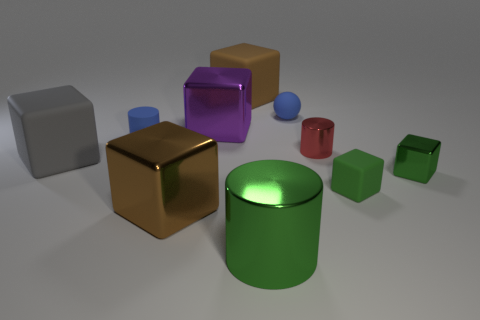Can you tell me how many objects in the image have cylindrical shapes? Certainly! In the image, there is one object with a cylindrical shape, which is the green cylinder. Cylindrical shapes are characterized by their curved surface and circular ends. What can you infer about the setting from the shadows and lighting in this scene? The shadows and lighting in the scene suggest a single diffuse light source, possibly overhead, given the soft and somewhat elongated shadows. This type of lighting is reminiscent of an indoor setting with ambient lighting, which softens the shadows and reduces contrast. 